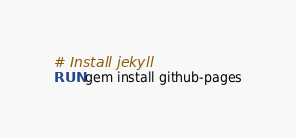<code> <loc_0><loc_0><loc_500><loc_500><_Dockerfile_># Install jekyll
RUN gem install github-pages
</code> 